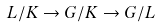<formula> <loc_0><loc_0><loc_500><loc_500>L / K \rightarrow G / K \rightarrow G / L</formula> 